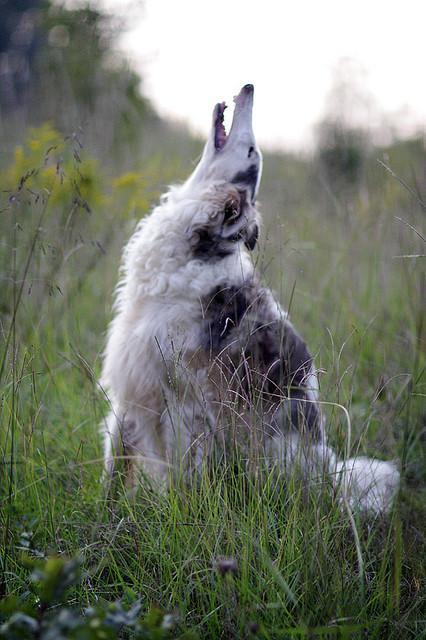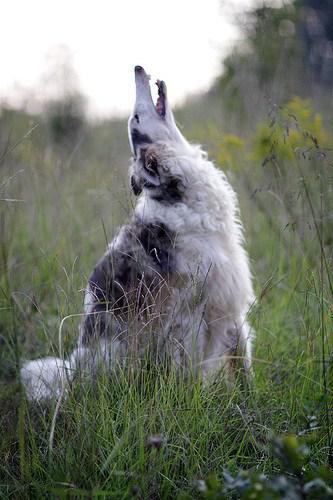The first image is the image on the left, the second image is the image on the right. Analyze the images presented: Is the assertion "There are two dogs" valid? Answer yes or no. Yes. 